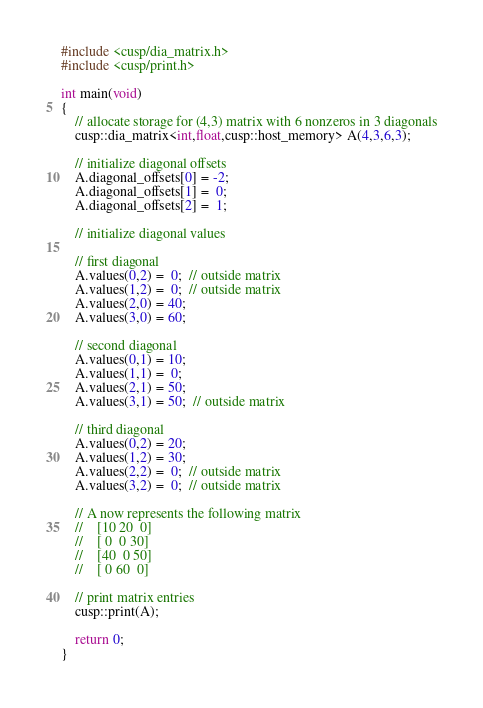Convert code to text. <code><loc_0><loc_0><loc_500><loc_500><_Cuda_>#include <cusp/dia_matrix.h>
#include <cusp/print.h>

int main(void)
{
    // allocate storage for (4,3) matrix with 6 nonzeros in 3 diagonals
    cusp::dia_matrix<int,float,cusp::host_memory> A(4,3,6,3);

    // initialize diagonal offsets
    A.diagonal_offsets[0] = -2;
    A.diagonal_offsets[1] =  0;
    A.diagonal_offsets[2] =  1;

    // initialize diagonal values

    // first diagonal
    A.values(0,2) =  0;  // outside matrix
    A.values(1,2) =  0;  // outside matrix
    A.values(2,0) = 40;
    A.values(3,0) = 60;
    
    // second diagonal
    A.values(0,1) = 10;
    A.values(1,1) =  0;
    A.values(2,1) = 50;
    A.values(3,1) = 50;  // outside matrix

    // third diagonal
    A.values(0,2) = 20;
    A.values(1,2) = 30;
    A.values(2,2) =  0;  // outside matrix
    A.values(3,2) =  0;  // outside matrix

    // A now represents the following matrix
    //    [10 20  0]
    //    [ 0  0 30]
    //    [40  0 50]
    //    [ 0 60  0]

    // print matrix entries
    cusp::print(A);

    return 0;
}

</code> 